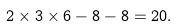<formula> <loc_0><loc_0><loc_500><loc_500>2 \times 3 \times 6 - 8 - 8 = 2 0 .</formula> 